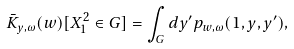Convert formula to latex. <formula><loc_0><loc_0><loc_500><loc_500>\bar { K } _ { y , \omega } ( w ) [ X ^ { 2 } _ { 1 } \in G ] = \int _ { G } d y ^ { \prime } p _ { w , \omega } ( 1 , y , y ^ { \prime } ) ,</formula> 